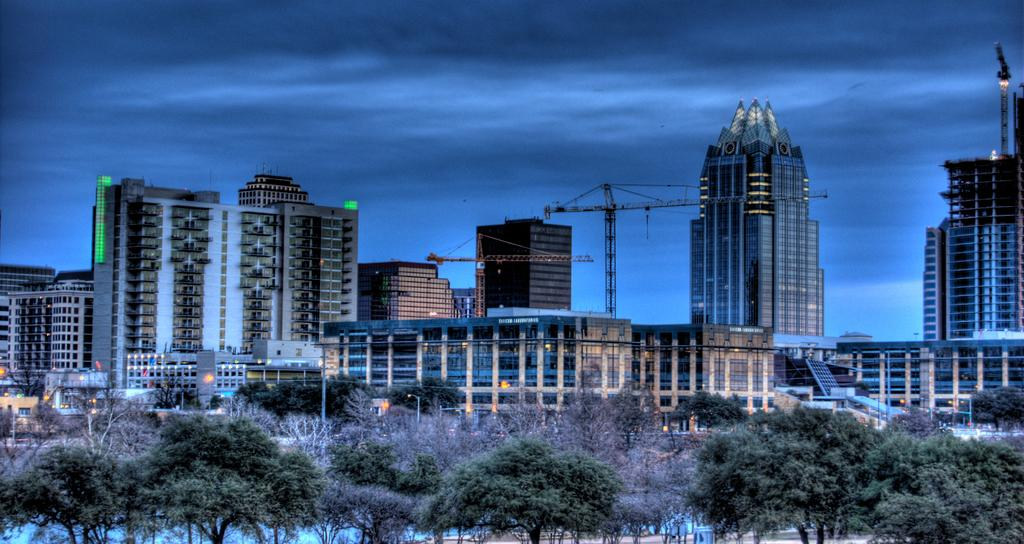What structures are located in the center of the image? There are buildings, towers, and poles in the center of the image. What is attached to the poles in the image? Lights are attached to the poles in the image. What type of vegetation is at the bottom of the image? There are trees at the bottom of the image. What is visible at the top of the image? The sky is visible at the top of the image. What type of weather can be seen in the image? There is no indication of weather in the image; it only shows buildings, towers, poles, lights, trees, and sky. Can you see a sail in the image? There is no sail present in the image. 